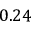Convert formula to latex. <formula><loc_0><loc_0><loc_500><loc_500>0 . 2 4</formula> 